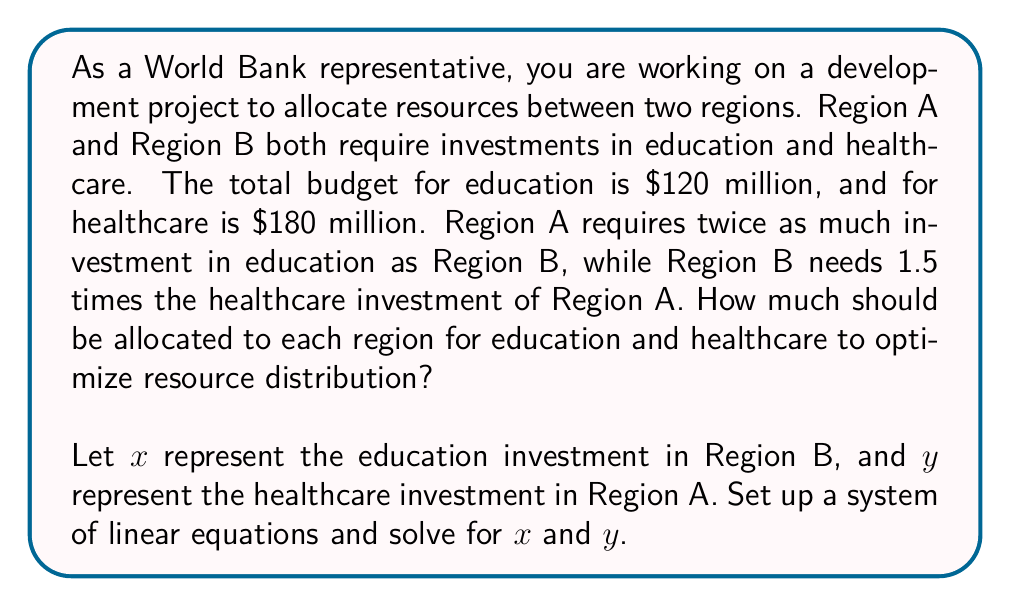Can you answer this question? Let's approach this step-by-step:

1) First, let's define our variables:
   $x$ = education investment in Region B
   $y$ = healthcare investment in Region A

2) Now, we can set up our system of equations based on the given information:

   For education: $2x + x = 120$ (Region A gets twice as much as B, total is $120 million)
   For healthcare: $y + 1.5y = 180$ (Region B gets 1.5 times as much as A, total is $180 million)

3) Simplify the equations:
   
   Education: $3x = 120$
   Healthcare: $2.5y = 180$

4) Solve for $x$ and $y$:

   $x = 120 / 3 = 40$
   $y = 180 / 2.5 = 72$

5) Now we can calculate the allocations for both regions:

   Region B education: $x = 40$ million
   Region A education: $2x = 2(40) = 80$ million

   Region A healthcare: $y = 72$ million
   Region B healthcare: $1.5y = 1.5(72) = 108$ million

6) Let's verify our solution:
   
   Education: $80 + 40 = 120$ million (matches total budget)
   Healthcare: $72 + 108 = 180$ million (matches total budget)

Therefore, our solution optimizes the resource allocation according to the given constraints.
Answer: The optimal resource allocation is:

Region A: $80 million for education, $72 million for healthcare
Region B: $40 million for education, $108 million for healthcare 